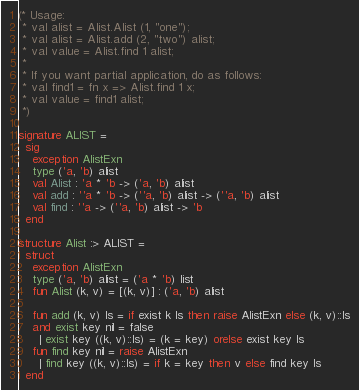<code> <loc_0><loc_0><loc_500><loc_500><_SML_>(* Usage:
 * val alist = Alist.Alist (1, "one");
 * val alist = Alist.add (2, "two") alist;
 * val value = Alist.find 1 alist;
 *
 * If you want partial application, do as follows:
 * val find1 = fn x => Alist.find 1 x;
 * val value = find1 alist;
 *)

signature ALIST =
  sig
    exception AlistExn
    type ('a, 'b) alist
    val Alist : 'a * 'b -> ('a, 'b) alist
    val add : ''a * 'b -> (''a, 'b) alist -> (''a, 'b) alist
    val find : ''a -> (''a, 'b) alist -> 'b
  end

structure Alist :> ALIST =
  struct
    exception AlistExn
    type ('a, 'b) alist = ('a * 'b) list
    fun Alist (k, v) = [(k, v)] : ('a, 'b) alist

    fun add (k, v) ls = if exist k ls then raise AlistExn else (k, v)::ls
    and exist key nil = false
      | exist key ((k, v)::ls) = (k = key) orelse exist key ls
    fun find key nil = raise AlistExn
      | find key ((k, v)::ls) = if k = key then v else find key ls
  end
</code> 